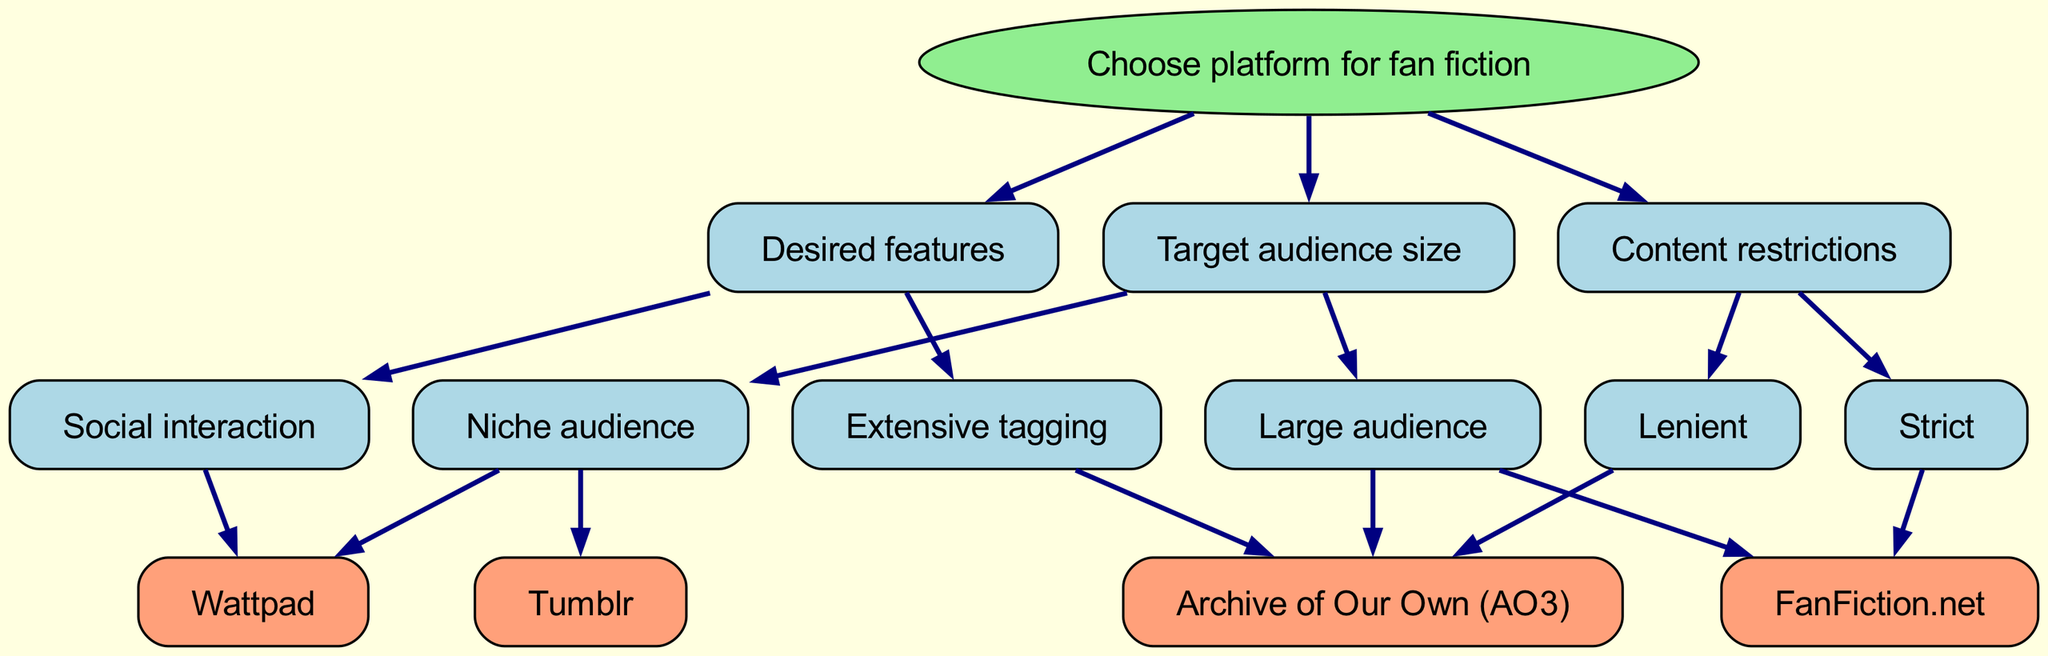What is the root node of the diagram? The root node is the starting point of the diagram, labeled as "Choose platform for fan fiction."
Answer: Choose platform for fan fiction How many options are available for a large audience? The diagram shows two children nodes under the "Large audience" node: "Archive of Our Own (AO3)" and "FanFiction.net." Thus, there are two options.
Answer: 2 Which platform is associated with extensive tagging? Under the 'Desired features' node, the branch for "Extensive tagging" leads to the "Archive of Our Own (AO3)" node.
Answer: Archive of Our Own (AO3) What is the outcome if the content restrictions are lenient? If the content restrictions are lenient, the flow goes to the "Archive of Our Own (AO3)" node. Therefore, the outcome would be this platform.
Answer: Archive of Our Own (AO3) Which platform caters to social interaction? The "Social interaction" branch specifically leads to the "Wattpad" node, indicating that it caters to social interaction features.
Answer: Wattpad If a user has a niche audience and desires extensive tagging, which platform should they choose? The "Niche audience" leads to "Wattpad," while "Extensive tagging" leads to "Archive of Our Own (AO3)." The two nodes are not connected, making it impossible to satisfy both conditions at once.
Answer: None What are the features that FanFiction.net offers? The diagram indicates "FanFiction.net" is linked under "Target audience size" with "Strict" content restrictions, but does not associate it with any special features.
Answer: Strict content restrictions Which platform is listed under both large audience and lenient content restrictions? The branches from "Large audience" and "Lenient" lead individually to "Archive of Our Own (AO3)." Since there is no overlap indicating it matches both categories, the answer is that it only matches one.
Answer: None 